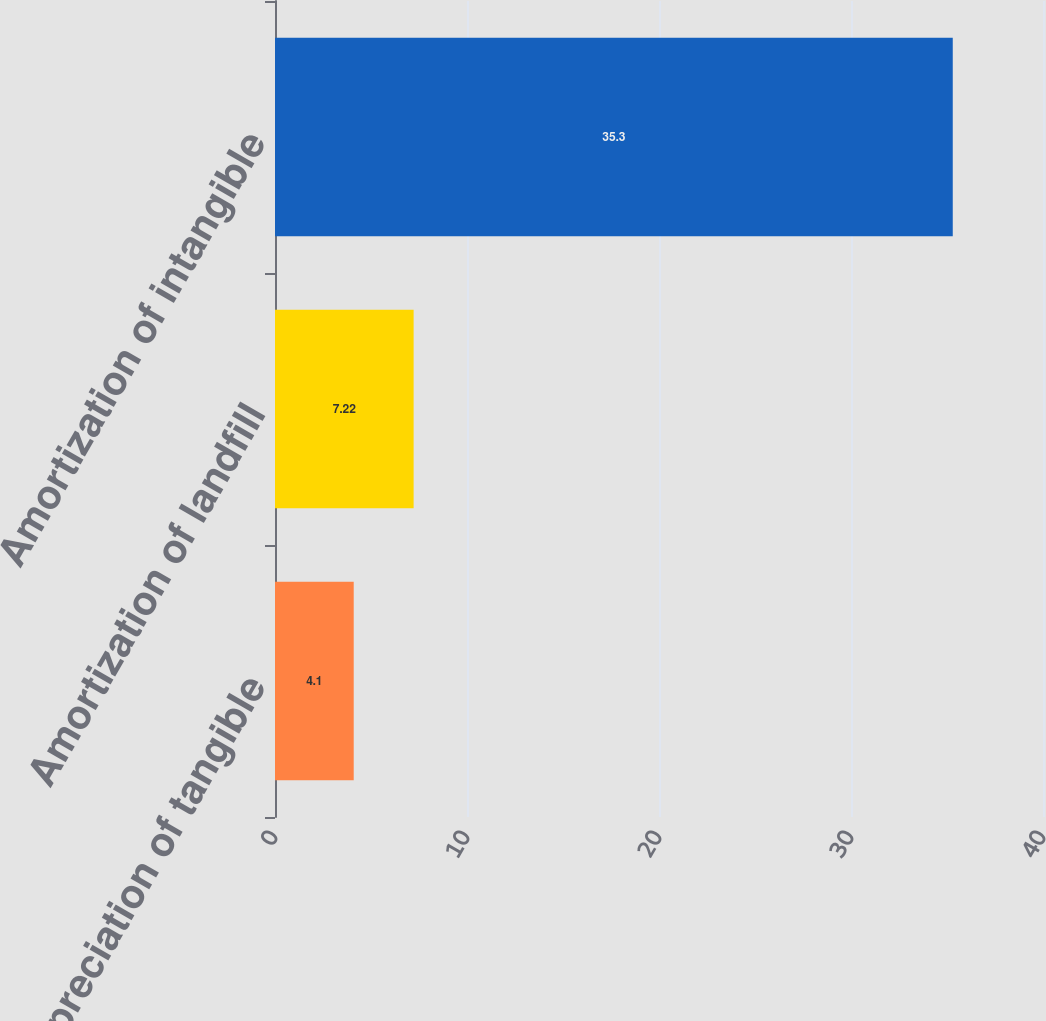<chart> <loc_0><loc_0><loc_500><loc_500><bar_chart><fcel>Depreciation of tangible<fcel>Amortization of landfill<fcel>Amortization of intangible<nl><fcel>4.1<fcel>7.22<fcel>35.3<nl></chart> 